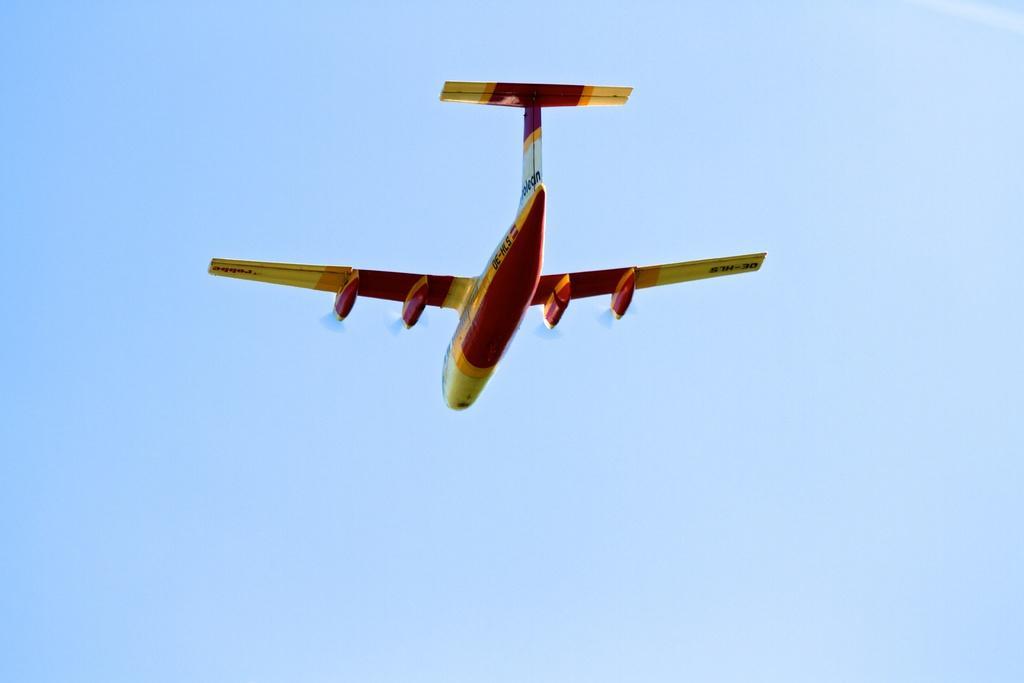How would you summarize this image in a sentence or two? In the image there is a plane flying in the sky, it is in red and yellow color. 